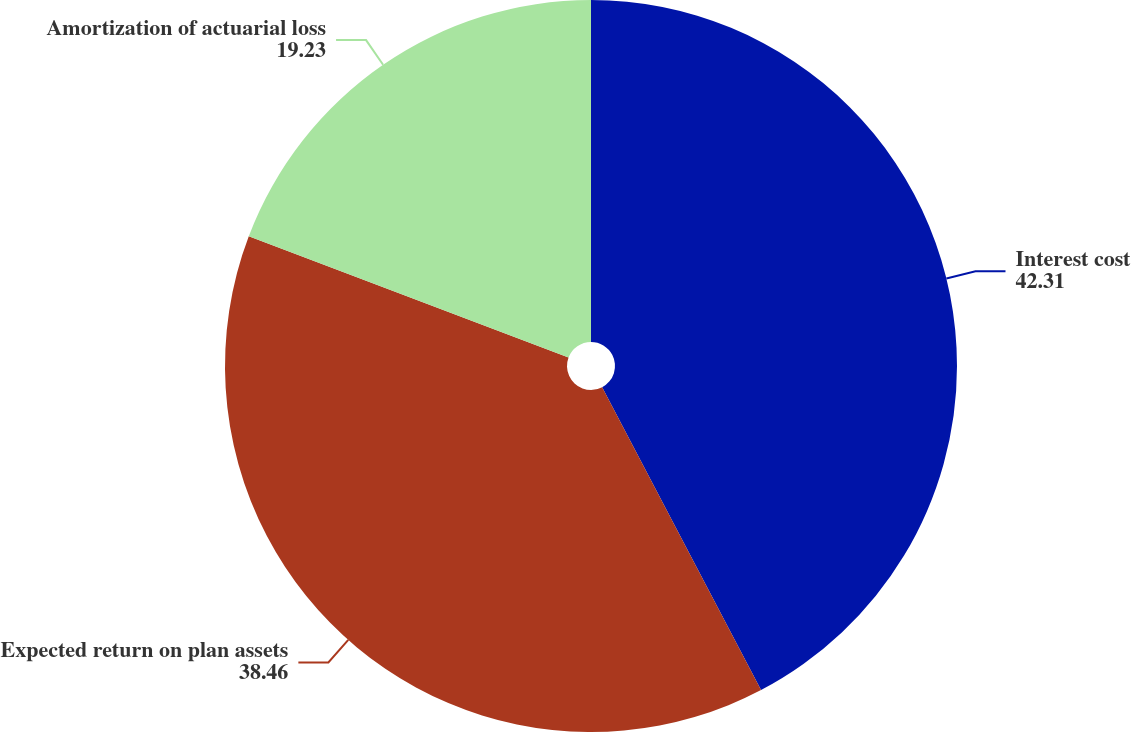Convert chart. <chart><loc_0><loc_0><loc_500><loc_500><pie_chart><fcel>Interest cost<fcel>Expected return on plan assets<fcel>Amortization of actuarial loss<nl><fcel>42.31%<fcel>38.46%<fcel>19.23%<nl></chart> 